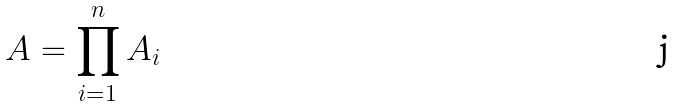<formula> <loc_0><loc_0><loc_500><loc_500>A = \prod _ { i = 1 } ^ { n } A _ { i }</formula> 